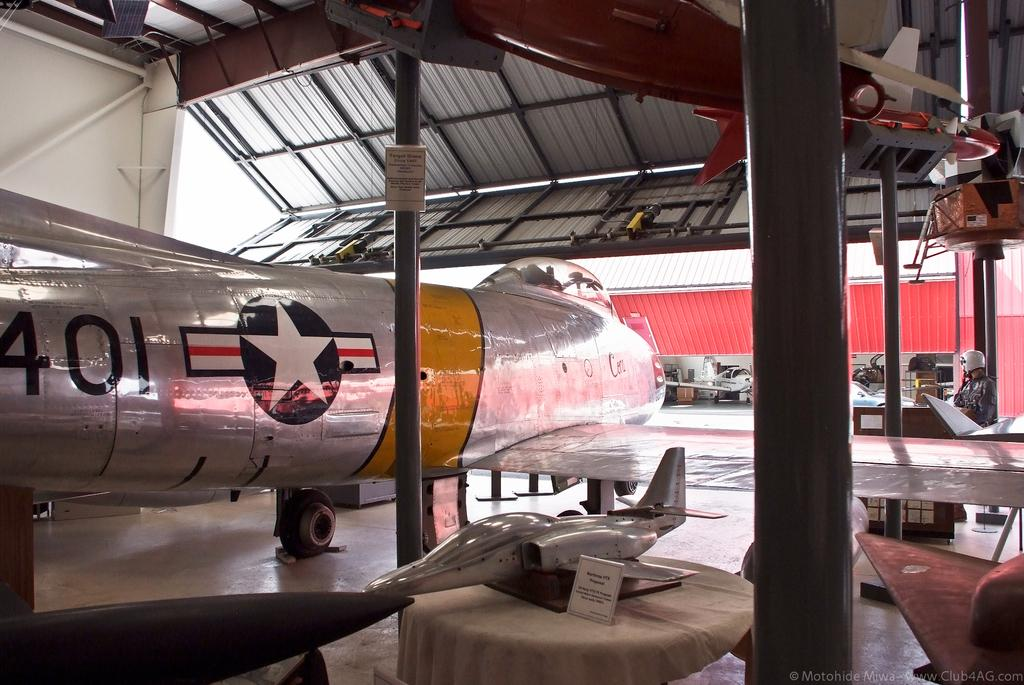What is the main subject of the image? The main subject of the image is an aeroplane. Where is the aeroplane located in the image? The aeroplane is under a shed in the image. What can be said about the appearance of the aeroplane? The aeroplane has a shiny color. What type of reaction can be seen in the library in the image? There is no library or reaction present in the image; it features an aeroplane under a shed. 